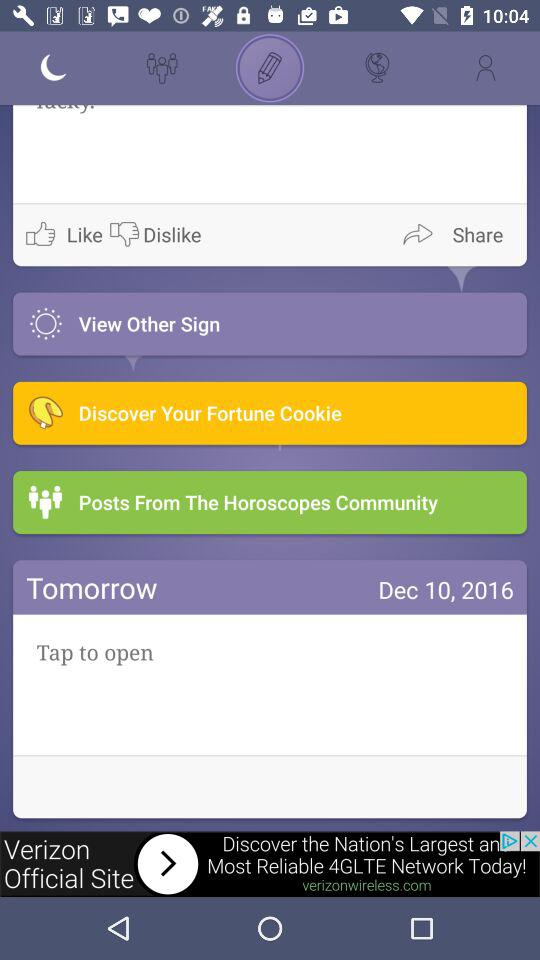What is the date shown on the screen? The shown date is December 10, 2016. 